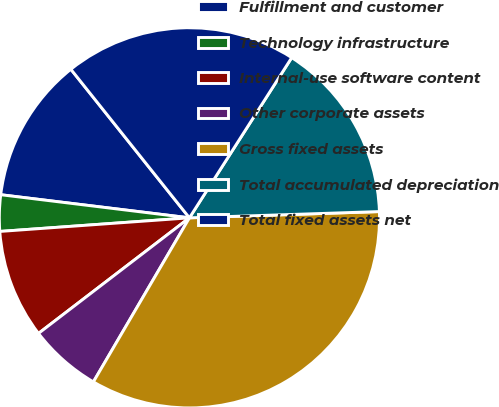Convert chart to OTSL. <chart><loc_0><loc_0><loc_500><loc_500><pie_chart><fcel>Fulfillment and customer<fcel>Technology infrastructure<fcel>Internal-use software content<fcel>Other corporate assets<fcel>Gross fixed assets<fcel>Total accumulated depreciation<fcel>Total fixed assets net<nl><fcel>12.34%<fcel>3.08%<fcel>9.26%<fcel>6.17%<fcel>33.95%<fcel>15.43%<fcel>19.76%<nl></chart> 